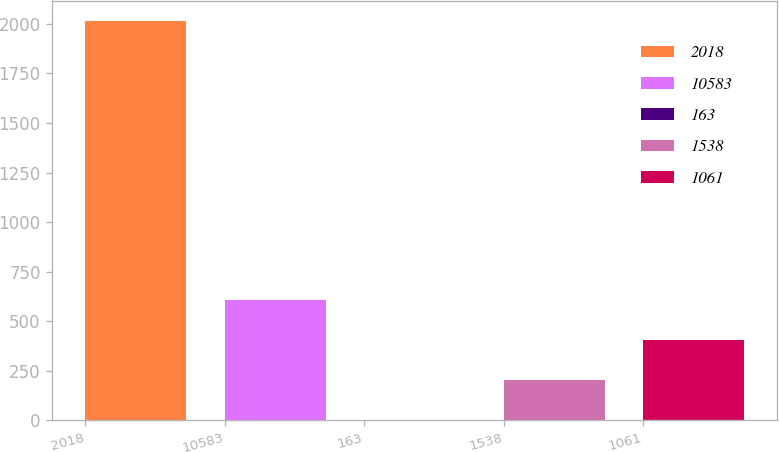Convert chart to OTSL. <chart><loc_0><loc_0><loc_500><loc_500><bar_chart><fcel>2018<fcel>10583<fcel>163<fcel>1538<fcel>1061<nl><fcel>2017<fcel>605.83<fcel>1.06<fcel>202.65<fcel>404.24<nl></chart> 